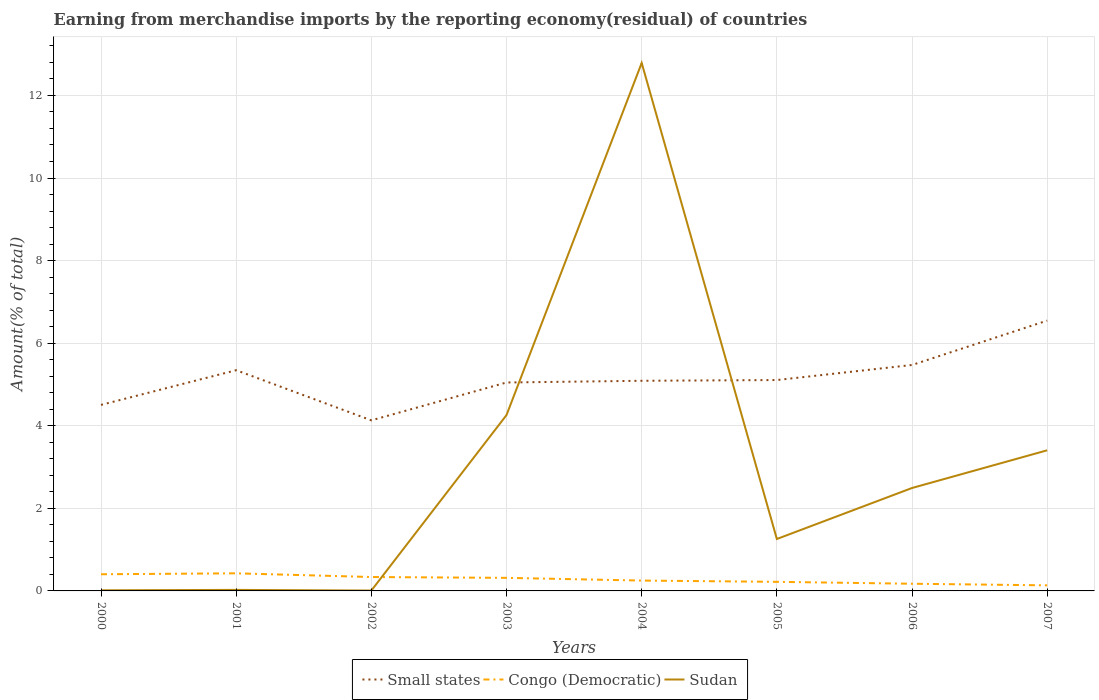Does the line corresponding to Sudan intersect with the line corresponding to Small states?
Keep it short and to the point. Yes. Is the number of lines equal to the number of legend labels?
Ensure brevity in your answer.  Yes. Across all years, what is the maximum percentage of amount earned from merchandise imports in Congo (Democratic)?
Offer a very short reply. 0.14. What is the total percentage of amount earned from merchandise imports in Small states in the graph?
Provide a succinct answer. -1.07. What is the difference between the highest and the second highest percentage of amount earned from merchandise imports in Congo (Democratic)?
Ensure brevity in your answer.  0.29. What is the difference between the highest and the lowest percentage of amount earned from merchandise imports in Sudan?
Keep it short and to the point. 3. Is the percentage of amount earned from merchandise imports in Small states strictly greater than the percentage of amount earned from merchandise imports in Sudan over the years?
Your response must be concise. No. What is the difference between two consecutive major ticks on the Y-axis?
Give a very brief answer. 2. Are the values on the major ticks of Y-axis written in scientific E-notation?
Make the answer very short. No. Does the graph contain grids?
Provide a short and direct response. Yes. How are the legend labels stacked?
Give a very brief answer. Horizontal. What is the title of the graph?
Provide a short and direct response. Earning from merchandise imports by the reporting economy(residual) of countries. Does "Aruba" appear as one of the legend labels in the graph?
Provide a succinct answer. No. What is the label or title of the X-axis?
Your answer should be compact. Years. What is the label or title of the Y-axis?
Give a very brief answer. Amount(% of total). What is the Amount(% of total) in Small states in 2000?
Your answer should be very brief. 4.51. What is the Amount(% of total) of Congo (Democratic) in 2000?
Make the answer very short. 0.4. What is the Amount(% of total) in Sudan in 2000?
Offer a terse response. 0.02. What is the Amount(% of total) in Small states in 2001?
Provide a short and direct response. 5.35. What is the Amount(% of total) of Congo (Democratic) in 2001?
Make the answer very short. 0.43. What is the Amount(% of total) of Sudan in 2001?
Offer a very short reply. 0.02. What is the Amount(% of total) in Small states in 2002?
Your answer should be compact. 4.13. What is the Amount(% of total) of Congo (Democratic) in 2002?
Keep it short and to the point. 0.34. What is the Amount(% of total) in Sudan in 2002?
Make the answer very short. 0.01. What is the Amount(% of total) in Small states in 2003?
Make the answer very short. 5.05. What is the Amount(% of total) of Congo (Democratic) in 2003?
Give a very brief answer. 0.32. What is the Amount(% of total) in Sudan in 2003?
Ensure brevity in your answer.  4.26. What is the Amount(% of total) of Small states in 2004?
Offer a very short reply. 5.09. What is the Amount(% of total) of Congo (Democratic) in 2004?
Give a very brief answer. 0.25. What is the Amount(% of total) of Sudan in 2004?
Provide a succinct answer. 12.79. What is the Amount(% of total) of Small states in 2005?
Provide a succinct answer. 5.11. What is the Amount(% of total) in Congo (Democratic) in 2005?
Your response must be concise. 0.22. What is the Amount(% of total) of Sudan in 2005?
Your response must be concise. 1.26. What is the Amount(% of total) of Small states in 2006?
Give a very brief answer. 5.47. What is the Amount(% of total) in Congo (Democratic) in 2006?
Offer a terse response. 0.17. What is the Amount(% of total) of Sudan in 2006?
Provide a short and direct response. 2.49. What is the Amount(% of total) of Small states in 2007?
Provide a succinct answer. 6.55. What is the Amount(% of total) of Congo (Democratic) in 2007?
Provide a short and direct response. 0.14. What is the Amount(% of total) of Sudan in 2007?
Ensure brevity in your answer.  3.41. Across all years, what is the maximum Amount(% of total) of Small states?
Your response must be concise. 6.55. Across all years, what is the maximum Amount(% of total) in Congo (Democratic)?
Ensure brevity in your answer.  0.43. Across all years, what is the maximum Amount(% of total) of Sudan?
Your answer should be very brief. 12.79. Across all years, what is the minimum Amount(% of total) in Small states?
Provide a short and direct response. 4.13. Across all years, what is the minimum Amount(% of total) in Congo (Democratic)?
Give a very brief answer. 0.14. Across all years, what is the minimum Amount(% of total) of Sudan?
Make the answer very short. 0.01. What is the total Amount(% of total) in Small states in the graph?
Your answer should be very brief. 41.24. What is the total Amount(% of total) in Congo (Democratic) in the graph?
Your answer should be compact. 2.26. What is the total Amount(% of total) in Sudan in the graph?
Your answer should be very brief. 24.25. What is the difference between the Amount(% of total) of Small states in 2000 and that in 2001?
Your response must be concise. -0.84. What is the difference between the Amount(% of total) of Congo (Democratic) in 2000 and that in 2001?
Offer a very short reply. -0.02. What is the difference between the Amount(% of total) in Sudan in 2000 and that in 2001?
Offer a very short reply. -0.01. What is the difference between the Amount(% of total) of Small states in 2000 and that in 2002?
Make the answer very short. 0.37. What is the difference between the Amount(% of total) in Congo (Democratic) in 2000 and that in 2002?
Keep it short and to the point. 0.07. What is the difference between the Amount(% of total) in Sudan in 2000 and that in 2002?
Keep it short and to the point. 0.01. What is the difference between the Amount(% of total) of Small states in 2000 and that in 2003?
Ensure brevity in your answer.  -0.54. What is the difference between the Amount(% of total) of Congo (Democratic) in 2000 and that in 2003?
Your response must be concise. 0.09. What is the difference between the Amount(% of total) in Sudan in 2000 and that in 2003?
Your response must be concise. -4.24. What is the difference between the Amount(% of total) of Small states in 2000 and that in 2004?
Provide a succinct answer. -0.58. What is the difference between the Amount(% of total) in Congo (Democratic) in 2000 and that in 2004?
Offer a terse response. 0.15. What is the difference between the Amount(% of total) of Sudan in 2000 and that in 2004?
Ensure brevity in your answer.  -12.77. What is the difference between the Amount(% of total) of Small states in 2000 and that in 2005?
Provide a succinct answer. -0.6. What is the difference between the Amount(% of total) of Congo (Democratic) in 2000 and that in 2005?
Keep it short and to the point. 0.18. What is the difference between the Amount(% of total) in Sudan in 2000 and that in 2005?
Make the answer very short. -1.24. What is the difference between the Amount(% of total) in Small states in 2000 and that in 2006?
Give a very brief answer. -0.97. What is the difference between the Amount(% of total) in Congo (Democratic) in 2000 and that in 2006?
Keep it short and to the point. 0.23. What is the difference between the Amount(% of total) in Sudan in 2000 and that in 2006?
Offer a very short reply. -2.48. What is the difference between the Amount(% of total) in Small states in 2000 and that in 2007?
Your response must be concise. -2.04. What is the difference between the Amount(% of total) of Congo (Democratic) in 2000 and that in 2007?
Provide a succinct answer. 0.27. What is the difference between the Amount(% of total) of Sudan in 2000 and that in 2007?
Ensure brevity in your answer.  -3.39. What is the difference between the Amount(% of total) of Small states in 2001 and that in 2002?
Offer a very short reply. 1.21. What is the difference between the Amount(% of total) in Congo (Democratic) in 2001 and that in 2002?
Ensure brevity in your answer.  0.09. What is the difference between the Amount(% of total) of Sudan in 2001 and that in 2002?
Provide a short and direct response. 0.02. What is the difference between the Amount(% of total) of Small states in 2001 and that in 2003?
Offer a terse response. 0.3. What is the difference between the Amount(% of total) in Congo (Democratic) in 2001 and that in 2003?
Make the answer very short. 0.11. What is the difference between the Amount(% of total) in Sudan in 2001 and that in 2003?
Your response must be concise. -4.23. What is the difference between the Amount(% of total) in Small states in 2001 and that in 2004?
Your response must be concise. 0.26. What is the difference between the Amount(% of total) of Congo (Democratic) in 2001 and that in 2004?
Ensure brevity in your answer.  0.18. What is the difference between the Amount(% of total) of Sudan in 2001 and that in 2004?
Your response must be concise. -12.76. What is the difference between the Amount(% of total) in Small states in 2001 and that in 2005?
Offer a very short reply. 0.24. What is the difference between the Amount(% of total) in Congo (Democratic) in 2001 and that in 2005?
Give a very brief answer. 0.21. What is the difference between the Amount(% of total) in Sudan in 2001 and that in 2005?
Make the answer very short. -1.23. What is the difference between the Amount(% of total) in Small states in 2001 and that in 2006?
Ensure brevity in your answer.  -0.13. What is the difference between the Amount(% of total) of Congo (Democratic) in 2001 and that in 2006?
Offer a terse response. 0.25. What is the difference between the Amount(% of total) of Sudan in 2001 and that in 2006?
Keep it short and to the point. -2.47. What is the difference between the Amount(% of total) of Small states in 2001 and that in 2007?
Offer a very short reply. -1.2. What is the difference between the Amount(% of total) in Congo (Democratic) in 2001 and that in 2007?
Offer a very short reply. 0.29. What is the difference between the Amount(% of total) of Sudan in 2001 and that in 2007?
Your answer should be compact. -3.38. What is the difference between the Amount(% of total) of Small states in 2002 and that in 2003?
Give a very brief answer. -0.92. What is the difference between the Amount(% of total) of Congo (Democratic) in 2002 and that in 2003?
Your response must be concise. 0.02. What is the difference between the Amount(% of total) in Sudan in 2002 and that in 2003?
Offer a terse response. -4.25. What is the difference between the Amount(% of total) in Small states in 2002 and that in 2004?
Offer a very short reply. -0.96. What is the difference between the Amount(% of total) in Congo (Democratic) in 2002 and that in 2004?
Your answer should be very brief. 0.09. What is the difference between the Amount(% of total) in Sudan in 2002 and that in 2004?
Offer a very short reply. -12.78. What is the difference between the Amount(% of total) of Small states in 2002 and that in 2005?
Offer a very short reply. -0.98. What is the difference between the Amount(% of total) of Congo (Democratic) in 2002 and that in 2005?
Your response must be concise. 0.12. What is the difference between the Amount(% of total) in Sudan in 2002 and that in 2005?
Ensure brevity in your answer.  -1.25. What is the difference between the Amount(% of total) in Small states in 2002 and that in 2006?
Offer a terse response. -1.34. What is the difference between the Amount(% of total) in Congo (Democratic) in 2002 and that in 2006?
Your response must be concise. 0.16. What is the difference between the Amount(% of total) in Sudan in 2002 and that in 2006?
Offer a very short reply. -2.48. What is the difference between the Amount(% of total) in Small states in 2002 and that in 2007?
Offer a very short reply. -2.42. What is the difference between the Amount(% of total) in Congo (Democratic) in 2002 and that in 2007?
Offer a terse response. 0.2. What is the difference between the Amount(% of total) of Sudan in 2002 and that in 2007?
Offer a very short reply. -3.4. What is the difference between the Amount(% of total) of Small states in 2003 and that in 2004?
Offer a very short reply. -0.04. What is the difference between the Amount(% of total) of Congo (Democratic) in 2003 and that in 2004?
Provide a succinct answer. 0.07. What is the difference between the Amount(% of total) of Sudan in 2003 and that in 2004?
Provide a succinct answer. -8.53. What is the difference between the Amount(% of total) of Small states in 2003 and that in 2005?
Give a very brief answer. -0.06. What is the difference between the Amount(% of total) of Congo (Democratic) in 2003 and that in 2005?
Your response must be concise. 0.1. What is the difference between the Amount(% of total) in Sudan in 2003 and that in 2005?
Ensure brevity in your answer.  3. What is the difference between the Amount(% of total) of Small states in 2003 and that in 2006?
Keep it short and to the point. -0.42. What is the difference between the Amount(% of total) of Congo (Democratic) in 2003 and that in 2006?
Offer a very short reply. 0.14. What is the difference between the Amount(% of total) in Sudan in 2003 and that in 2006?
Make the answer very short. 1.77. What is the difference between the Amount(% of total) of Small states in 2003 and that in 2007?
Offer a terse response. -1.5. What is the difference between the Amount(% of total) in Congo (Democratic) in 2003 and that in 2007?
Provide a succinct answer. 0.18. What is the difference between the Amount(% of total) of Sudan in 2003 and that in 2007?
Give a very brief answer. 0.85. What is the difference between the Amount(% of total) in Small states in 2004 and that in 2005?
Provide a succinct answer. -0.02. What is the difference between the Amount(% of total) of Congo (Democratic) in 2004 and that in 2005?
Offer a terse response. 0.03. What is the difference between the Amount(% of total) of Sudan in 2004 and that in 2005?
Make the answer very short. 11.53. What is the difference between the Amount(% of total) in Small states in 2004 and that in 2006?
Provide a succinct answer. -0.38. What is the difference between the Amount(% of total) in Congo (Democratic) in 2004 and that in 2006?
Offer a very short reply. 0.08. What is the difference between the Amount(% of total) of Sudan in 2004 and that in 2006?
Offer a terse response. 10.29. What is the difference between the Amount(% of total) in Small states in 2004 and that in 2007?
Ensure brevity in your answer.  -1.46. What is the difference between the Amount(% of total) in Congo (Democratic) in 2004 and that in 2007?
Offer a terse response. 0.12. What is the difference between the Amount(% of total) of Sudan in 2004 and that in 2007?
Give a very brief answer. 9.38. What is the difference between the Amount(% of total) of Small states in 2005 and that in 2006?
Ensure brevity in your answer.  -0.36. What is the difference between the Amount(% of total) in Congo (Democratic) in 2005 and that in 2006?
Make the answer very short. 0.05. What is the difference between the Amount(% of total) in Sudan in 2005 and that in 2006?
Ensure brevity in your answer.  -1.24. What is the difference between the Amount(% of total) in Small states in 2005 and that in 2007?
Your response must be concise. -1.44. What is the difference between the Amount(% of total) of Congo (Democratic) in 2005 and that in 2007?
Provide a short and direct response. 0.09. What is the difference between the Amount(% of total) of Sudan in 2005 and that in 2007?
Keep it short and to the point. -2.15. What is the difference between the Amount(% of total) in Small states in 2006 and that in 2007?
Offer a very short reply. -1.07. What is the difference between the Amount(% of total) in Congo (Democratic) in 2006 and that in 2007?
Your answer should be very brief. 0.04. What is the difference between the Amount(% of total) in Sudan in 2006 and that in 2007?
Give a very brief answer. -0.91. What is the difference between the Amount(% of total) of Small states in 2000 and the Amount(% of total) of Congo (Democratic) in 2001?
Provide a succinct answer. 4.08. What is the difference between the Amount(% of total) in Small states in 2000 and the Amount(% of total) in Sudan in 2001?
Your answer should be compact. 4.48. What is the difference between the Amount(% of total) in Congo (Democratic) in 2000 and the Amount(% of total) in Sudan in 2001?
Your response must be concise. 0.38. What is the difference between the Amount(% of total) of Small states in 2000 and the Amount(% of total) of Congo (Democratic) in 2002?
Ensure brevity in your answer.  4.17. What is the difference between the Amount(% of total) of Small states in 2000 and the Amount(% of total) of Sudan in 2002?
Provide a succinct answer. 4.5. What is the difference between the Amount(% of total) of Congo (Democratic) in 2000 and the Amount(% of total) of Sudan in 2002?
Give a very brief answer. 0.39. What is the difference between the Amount(% of total) of Small states in 2000 and the Amount(% of total) of Congo (Democratic) in 2003?
Give a very brief answer. 4.19. What is the difference between the Amount(% of total) in Small states in 2000 and the Amount(% of total) in Sudan in 2003?
Provide a short and direct response. 0.25. What is the difference between the Amount(% of total) in Congo (Democratic) in 2000 and the Amount(% of total) in Sudan in 2003?
Offer a terse response. -3.86. What is the difference between the Amount(% of total) in Small states in 2000 and the Amount(% of total) in Congo (Democratic) in 2004?
Your answer should be very brief. 4.25. What is the difference between the Amount(% of total) in Small states in 2000 and the Amount(% of total) in Sudan in 2004?
Provide a succinct answer. -8.28. What is the difference between the Amount(% of total) in Congo (Democratic) in 2000 and the Amount(% of total) in Sudan in 2004?
Ensure brevity in your answer.  -12.38. What is the difference between the Amount(% of total) in Small states in 2000 and the Amount(% of total) in Congo (Democratic) in 2005?
Give a very brief answer. 4.29. What is the difference between the Amount(% of total) of Small states in 2000 and the Amount(% of total) of Sudan in 2005?
Offer a terse response. 3.25. What is the difference between the Amount(% of total) in Congo (Democratic) in 2000 and the Amount(% of total) in Sudan in 2005?
Provide a succinct answer. -0.85. What is the difference between the Amount(% of total) in Small states in 2000 and the Amount(% of total) in Congo (Democratic) in 2006?
Give a very brief answer. 4.33. What is the difference between the Amount(% of total) in Small states in 2000 and the Amount(% of total) in Sudan in 2006?
Ensure brevity in your answer.  2.01. What is the difference between the Amount(% of total) in Congo (Democratic) in 2000 and the Amount(% of total) in Sudan in 2006?
Offer a terse response. -2.09. What is the difference between the Amount(% of total) in Small states in 2000 and the Amount(% of total) in Congo (Democratic) in 2007?
Make the answer very short. 4.37. What is the difference between the Amount(% of total) in Small states in 2000 and the Amount(% of total) in Sudan in 2007?
Ensure brevity in your answer.  1.1. What is the difference between the Amount(% of total) in Congo (Democratic) in 2000 and the Amount(% of total) in Sudan in 2007?
Offer a very short reply. -3. What is the difference between the Amount(% of total) of Small states in 2001 and the Amount(% of total) of Congo (Democratic) in 2002?
Offer a very short reply. 5.01. What is the difference between the Amount(% of total) in Small states in 2001 and the Amount(% of total) in Sudan in 2002?
Offer a very short reply. 5.34. What is the difference between the Amount(% of total) in Congo (Democratic) in 2001 and the Amount(% of total) in Sudan in 2002?
Offer a terse response. 0.42. What is the difference between the Amount(% of total) of Small states in 2001 and the Amount(% of total) of Congo (Democratic) in 2003?
Offer a very short reply. 5.03. What is the difference between the Amount(% of total) of Small states in 2001 and the Amount(% of total) of Sudan in 2003?
Make the answer very short. 1.09. What is the difference between the Amount(% of total) of Congo (Democratic) in 2001 and the Amount(% of total) of Sudan in 2003?
Your answer should be compact. -3.83. What is the difference between the Amount(% of total) in Small states in 2001 and the Amount(% of total) in Congo (Democratic) in 2004?
Make the answer very short. 5.09. What is the difference between the Amount(% of total) in Small states in 2001 and the Amount(% of total) in Sudan in 2004?
Provide a succinct answer. -7.44. What is the difference between the Amount(% of total) of Congo (Democratic) in 2001 and the Amount(% of total) of Sudan in 2004?
Make the answer very short. -12.36. What is the difference between the Amount(% of total) in Small states in 2001 and the Amount(% of total) in Congo (Democratic) in 2005?
Keep it short and to the point. 5.13. What is the difference between the Amount(% of total) of Small states in 2001 and the Amount(% of total) of Sudan in 2005?
Offer a terse response. 4.09. What is the difference between the Amount(% of total) of Congo (Democratic) in 2001 and the Amount(% of total) of Sudan in 2005?
Ensure brevity in your answer.  -0.83. What is the difference between the Amount(% of total) of Small states in 2001 and the Amount(% of total) of Congo (Democratic) in 2006?
Ensure brevity in your answer.  5.17. What is the difference between the Amount(% of total) in Small states in 2001 and the Amount(% of total) in Sudan in 2006?
Keep it short and to the point. 2.85. What is the difference between the Amount(% of total) in Congo (Democratic) in 2001 and the Amount(% of total) in Sudan in 2006?
Give a very brief answer. -2.07. What is the difference between the Amount(% of total) of Small states in 2001 and the Amount(% of total) of Congo (Democratic) in 2007?
Provide a short and direct response. 5.21. What is the difference between the Amount(% of total) in Small states in 2001 and the Amount(% of total) in Sudan in 2007?
Provide a short and direct response. 1.94. What is the difference between the Amount(% of total) of Congo (Democratic) in 2001 and the Amount(% of total) of Sudan in 2007?
Give a very brief answer. -2.98. What is the difference between the Amount(% of total) in Small states in 2002 and the Amount(% of total) in Congo (Democratic) in 2003?
Offer a very short reply. 3.81. What is the difference between the Amount(% of total) in Small states in 2002 and the Amount(% of total) in Sudan in 2003?
Your response must be concise. -0.13. What is the difference between the Amount(% of total) of Congo (Democratic) in 2002 and the Amount(% of total) of Sudan in 2003?
Ensure brevity in your answer.  -3.92. What is the difference between the Amount(% of total) in Small states in 2002 and the Amount(% of total) in Congo (Democratic) in 2004?
Your answer should be very brief. 3.88. What is the difference between the Amount(% of total) in Small states in 2002 and the Amount(% of total) in Sudan in 2004?
Provide a short and direct response. -8.66. What is the difference between the Amount(% of total) in Congo (Democratic) in 2002 and the Amount(% of total) in Sudan in 2004?
Your answer should be very brief. -12.45. What is the difference between the Amount(% of total) of Small states in 2002 and the Amount(% of total) of Congo (Democratic) in 2005?
Offer a terse response. 3.91. What is the difference between the Amount(% of total) in Small states in 2002 and the Amount(% of total) in Sudan in 2005?
Make the answer very short. 2.87. What is the difference between the Amount(% of total) of Congo (Democratic) in 2002 and the Amount(% of total) of Sudan in 2005?
Offer a terse response. -0.92. What is the difference between the Amount(% of total) in Small states in 2002 and the Amount(% of total) in Congo (Democratic) in 2006?
Keep it short and to the point. 3.96. What is the difference between the Amount(% of total) of Small states in 2002 and the Amount(% of total) of Sudan in 2006?
Your answer should be compact. 1.64. What is the difference between the Amount(% of total) of Congo (Democratic) in 2002 and the Amount(% of total) of Sudan in 2006?
Your response must be concise. -2.16. What is the difference between the Amount(% of total) of Small states in 2002 and the Amount(% of total) of Congo (Democratic) in 2007?
Make the answer very short. 4. What is the difference between the Amount(% of total) of Small states in 2002 and the Amount(% of total) of Sudan in 2007?
Your answer should be very brief. 0.73. What is the difference between the Amount(% of total) in Congo (Democratic) in 2002 and the Amount(% of total) in Sudan in 2007?
Offer a terse response. -3.07. What is the difference between the Amount(% of total) of Small states in 2003 and the Amount(% of total) of Congo (Democratic) in 2004?
Provide a short and direct response. 4.8. What is the difference between the Amount(% of total) in Small states in 2003 and the Amount(% of total) in Sudan in 2004?
Provide a succinct answer. -7.74. What is the difference between the Amount(% of total) in Congo (Democratic) in 2003 and the Amount(% of total) in Sudan in 2004?
Provide a short and direct response. -12.47. What is the difference between the Amount(% of total) in Small states in 2003 and the Amount(% of total) in Congo (Democratic) in 2005?
Your response must be concise. 4.83. What is the difference between the Amount(% of total) of Small states in 2003 and the Amount(% of total) of Sudan in 2005?
Keep it short and to the point. 3.79. What is the difference between the Amount(% of total) in Congo (Democratic) in 2003 and the Amount(% of total) in Sudan in 2005?
Keep it short and to the point. -0.94. What is the difference between the Amount(% of total) of Small states in 2003 and the Amount(% of total) of Congo (Democratic) in 2006?
Offer a very short reply. 4.87. What is the difference between the Amount(% of total) of Small states in 2003 and the Amount(% of total) of Sudan in 2006?
Offer a terse response. 2.56. What is the difference between the Amount(% of total) of Congo (Democratic) in 2003 and the Amount(% of total) of Sudan in 2006?
Keep it short and to the point. -2.18. What is the difference between the Amount(% of total) in Small states in 2003 and the Amount(% of total) in Congo (Democratic) in 2007?
Offer a very short reply. 4.91. What is the difference between the Amount(% of total) of Small states in 2003 and the Amount(% of total) of Sudan in 2007?
Keep it short and to the point. 1.64. What is the difference between the Amount(% of total) of Congo (Democratic) in 2003 and the Amount(% of total) of Sudan in 2007?
Offer a very short reply. -3.09. What is the difference between the Amount(% of total) in Small states in 2004 and the Amount(% of total) in Congo (Democratic) in 2005?
Make the answer very short. 4.87. What is the difference between the Amount(% of total) of Small states in 2004 and the Amount(% of total) of Sudan in 2005?
Give a very brief answer. 3.83. What is the difference between the Amount(% of total) of Congo (Democratic) in 2004 and the Amount(% of total) of Sudan in 2005?
Provide a short and direct response. -1.01. What is the difference between the Amount(% of total) of Small states in 2004 and the Amount(% of total) of Congo (Democratic) in 2006?
Keep it short and to the point. 4.92. What is the difference between the Amount(% of total) of Small states in 2004 and the Amount(% of total) of Sudan in 2006?
Your answer should be very brief. 2.6. What is the difference between the Amount(% of total) of Congo (Democratic) in 2004 and the Amount(% of total) of Sudan in 2006?
Keep it short and to the point. -2.24. What is the difference between the Amount(% of total) in Small states in 2004 and the Amount(% of total) in Congo (Democratic) in 2007?
Offer a terse response. 4.95. What is the difference between the Amount(% of total) of Small states in 2004 and the Amount(% of total) of Sudan in 2007?
Offer a very short reply. 1.68. What is the difference between the Amount(% of total) of Congo (Democratic) in 2004 and the Amount(% of total) of Sudan in 2007?
Offer a very short reply. -3.15. What is the difference between the Amount(% of total) in Small states in 2005 and the Amount(% of total) in Congo (Democratic) in 2006?
Provide a succinct answer. 4.93. What is the difference between the Amount(% of total) of Small states in 2005 and the Amount(% of total) of Sudan in 2006?
Your answer should be very brief. 2.61. What is the difference between the Amount(% of total) of Congo (Democratic) in 2005 and the Amount(% of total) of Sudan in 2006?
Give a very brief answer. -2.27. What is the difference between the Amount(% of total) of Small states in 2005 and the Amount(% of total) of Congo (Democratic) in 2007?
Your answer should be very brief. 4.97. What is the difference between the Amount(% of total) of Small states in 2005 and the Amount(% of total) of Sudan in 2007?
Offer a terse response. 1.7. What is the difference between the Amount(% of total) in Congo (Democratic) in 2005 and the Amount(% of total) in Sudan in 2007?
Provide a succinct answer. -3.19. What is the difference between the Amount(% of total) in Small states in 2006 and the Amount(% of total) in Congo (Democratic) in 2007?
Give a very brief answer. 5.34. What is the difference between the Amount(% of total) of Small states in 2006 and the Amount(% of total) of Sudan in 2007?
Give a very brief answer. 2.07. What is the difference between the Amount(% of total) of Congo (Democratic) in 2006 and the Amount(% of total) of Sudan in 2007?
Ensure brevity in your answer.  -3.23. What is the average Amount(% of total) of Small states per year?
Offer a terse response. 5.16. What is the average Amount(% of total) of Congo (Democratic) per year?
Your answer should be compact. 0.28. What is the average Amount(% of total) in Sudan per year?
Make the answer very short. 3.03. In the year 2000, what is the difference between the Amount(% of total) in Small states and Amount(% of total) in Congo (Democratic)?
Give a very brief answer. 4.1. In the year 2000, what is the difference between the Amount(% of total) of Small states and Amount(% of total) of Sudan?
Make the answer very short. 4.49. In the year 2000, what is the difference between the Amount(% of total) in Congo (Democratic) and Amount(% of total) in Sudan?
Provide a succinct answer. 0.39. In the year 2001, what is the difference between the Amount(% of total) of Small states and Amount(% of total) of Congo (Democratic)?
Provide a short and direct response. 4.92. In the year 2001, what is the difference between the Amount(% of total) in Small states and Amount(% of total) in Sudan?
Your response must be concise. 5.32. In the year 2001, what is the difference between the Amount(% of total) in Congo (Democratic) and Amount(% of total) in Sudan?
Offer a very short reply. 0.4. In the year 2002, what is the difference between the Amount(% of total) of Small states and Amount(% of total) of Congo (Democratic)?
Ensure brevity in your answer.  3.79. In the year 2002, what is the difference between the Amount(% of total) in Small states and Amount(% of total) in Sudan?
Ensure brevity in your answer.  4.12. In the year 2002, what is the difference between the Amount(% of total) of Congo (Democratic) and Amount(% of total) of Sudan?
Your answer should be very brief. 0.33. In the year 2003, what is the difference between the Amount(% of total) in Small states and Amount(% of total) in Congo (Democratic)?
Make the answer very short. 4.73. In the year 2003, what is the difference between the Amount(% of total) in Small states and Amount(% of total) in Sudan?
Provide a short and direct response. 0.79. In the year 2003, what is the difference between the Amount(% of total) in Congo (Democratic) and Amount(% of total) in Sudan?
Give a very brief answer. -3.94. In the year 2004, what is the difference between the Amount(% of total) in Small states and Amount(% of total) in Congo (Democratic)?
Your answer should be compact. 4.84. In the year 2004, what is the difference between the Amount(% of total) of Small states and Amount(% of total) of Sudan?
Offer a terse response. -7.7. In the year 2004, what is the difference between the Amount(% of total) of Congo (Democratic) and Amount(% of total) of Sudan?
Keep it short and to the point. -12.54. In the year 2005, what is the difference between the Amount(% of total) of Small states and Amount(% of total) of Congo (Democratic)?
Give a very brief answer. 4.89. In the year 2005, what is the difference between the Amount(% of total) of Small states and Amount(% of total) of Sudan?
Your response must be concise. 3.85. In the year 2005, what is the difference between the Amount(% of total) in Congo (Democratic) and Amount(% of total) in Sudan?
Keep it short and to the point. -1.04. In the year 2006, what is the difference between the Amount(% of total) in Small states and Amount(% of total) in Congo (Democratic)?
Your answer should be very brief. 5.3. In the year 2006, what is the difference between the Amount(% of total) of Small states and Amount(% of total) of Sudan?
Your answer should be compact. 2.98. In the year 2006, what is the difference between the Amount(% of total) of Congo (Democratic) and Amount(% of total) of Sudan?
Provide a succinct answer. -2.32. In the year 2007, what is the difference between the Amount(% of total) in Small states and Amount(% of total) in Congo (Democratic)?
Provide a short and direct response. 6.41. In the year 2007, what is the difference between the Amount(% of total) of Small states and Amount(% of total) of Sudan?
Your answer should be compact. 3.14. In the year 2007, what is the difference between the Amount(% of total) in Congo (Democratic) and Amount(% of total) in Sudan?
Your answer should be very brief. -3.27. What is the ratio of the Amount(% of total) of Small states in 2000 to that in 2001?
Provide a succinct answer. 0.84. What is the ratio of the Amount(% of total) in Congo (Democratic) in 2000 to that in 2001?
Offer a terse response. 0.95. What is the ratio of the Amount(% of total) in Sudan in 2000 to that in 2001?
Your response must be concise. 0.61. What is the ratio of the Amount(% of total) of Small states in 2000 to that in 2002?
Your answer should be very brief. 1.09. What is the ratio of the Amount(% of total) in Congo (Democratic) in 2000 to that in 2002?
Your answer should be very brief. 1.2. What is the ratio of the Amount(% of total) in Sudan in 2000 to that in 2002?
Keep it short and to the point. 1.69. What is the ratio of the Amount(% of total) of Small states in 2000 to that in 2003?
Provide a short and direct response. 0.89. What is the ratio of the Amount(% of total) of Congo (Democratic) in 2000 to that in 2003?
Give a very brief answer. 1.28. What is the ratio of the Amount(% of total) of Sudan in 2000 to that in 2003?
Provide a short and direct response. 0. What is the ratio of the Amount(% of total) in Small states in 2000 to that in 2004?
Your answer should be very brief. 0.89. What is the ratio of the Amount(% of total) of Congo (Democratic) in 2000 to that in 2004?
Offer a very short reply. 1.61. What is the ratio of the Amount(% of total) of Sudan in 2000 to that in 2004?
Provide a short and direct response. 0. What is the ratio of the Amount(% of total) in Small states in 2000 to that in 2005?
Give a very brief answer. 0.88. What is the ratio of the Amount(% of total) in Congo (Democratic) in 2000 to that in 2005?
Give a very brief answer. 1.83. What is the ratio of the Amount(% of total) of Sudan in 2000 to that in 2005?
Keep it short and to the point. 0.01. What is the ratio of the Amount(% of total) of Small states in 2000 to that in 2006?
Provide a short and direct response. 0.82. What is the ratio of the Amount(% of total) of Congo (Democratic) in 2000 to that in 2006?
Your answer should be compact. 2.32. What is the ratio of the Amount(% of total) in Sudan in 2000 to that in 2006?
Make the answer very short. 0.01. What is the ratio of the Amount(% of total) of Small states in 2000 to that in 2007?
Ensure brevity in your answer.  0.69. What is the ratio of the Amount(% of total) of Congo (Democratic) in 2000 to that in 2007?
Your answer should be very brief. 2.99. What is the ratio of the Amount(% of total) in Sudan in 2000 to that in 2007?
Make the answer very short. 0. What is the ratio of the Amount(% of total) of Small states in 2001 to that in 2002?
Your answer should be very brief. 1.29. What is the ratio of the Amount(% of total) of Congo (Democratic) in 2001 to that in 2002?
Your response must be concise. 1.27. What is the ratio of the Amount(% of total) in Sudan in 2001 to that in 2002?
Keep it short and to the point. 2.8. What is the ratio of the Amount(% of total) of Small states in 2001 to that in 2003?
Provide a short and direct response. 1.06. What is the ratio of the Amount(% of total) of Congo (Democratic) in 2001 to that in 2003?
Ensure brevity in your answer.  1.35. What is the ratio of the Amount(% of total) of Sudan in 2001 to that in 2003?
Provide a succinct answer. 0.01. What is the ratio of the Amount(% of total) of Small states in 2001 to that in 2004?
Give a very brief answer. 1.05. What is the ratio of the Amount(% of total) in Congo (Democratic) in 2001 to that in 2004?
Your answer should be compact. 1.7. What is the ratio of the Amount(% of total) of Sudan in 2001 to that in 2004?
Offer a terse response. 0. What is the ratio of the Amount(% of total) of Small states in 2001 to that in 2005?
Offer a very short reply. 1.05. What is the ratio of the Amount(% of total) of Congo (Democratic) in 2001 to that in 2005?
Give a very brief answer. 1.94. What is the ratio of the Amount(% of total) in Sudan in 2001 to that in 2005?
Your answer should be very brief. 0.02. What is the ratio of the Amount(% of total) in Small states in 2001 to that in 2006?
Keep it short and to the point. 0.98. What is the ratio of the Amount(% of total) in Congo (Democratic) in 2001 to that in 2006?
Ensure brevity in your answer.  2.45. What is the ratio of the Amount(% of total) of Sudan in 2001 to that in 2006?
Give a very brief answer. 0.01. What is the ratio of the Amount(% of total) in Small states in 2001 to that in 2007?
Provide a succinct answer. 0.82. What is the ratio of the Amount(% of total) in Congo (Democratic) in 2001 to that in 2007?
Your answer should be compact. 3.16. What is the ratio of the Amount(% of total) of Sudan in 2001 to that in 2007?
Keep it short and to the point. 0.01. What is the ratio of the Amount(% of total) in Small states in 2002 to that in 2003?
Give a very brief answer. 0.82. What is the ratio of the Amount(% of total) of Congo (Democratic) in 2002 to that in 2003?
Ensure brevity in your answer.  1.06. What is the ratio of the Amount(% of total) in Sudan in 2002 to that in 2003?
Make the answer very short. 0. What is the ratio of the Amount(% of total) of Small states in 2002 to that in 2004?
Provide a succinct answer. 0.81. What is the ratio of the Amount(% of total) of Congo (Democratic) in 2002 to that in 2004?
Keep it short and to the point. 1.34. What is the ratio of the Amount(% of total) of Sudan in 2002 to that in 2004?
Make the answer very short. 0. What is the ratio of the Amount(% of total) in Small states in 2002 to that in 2005?
Give a very brief answer. 0.81. What is the ratio of the Amount(% of total) of Congo (Democratic) in 2002 to that in 2005?
Give a very brief answer. 1.53. What is the ratio of the Amount(% of total) in Sudan in 2002 to that in 2005?
Offer a terse response. 0.01. What is the ratio of the Amount(% of total) of Small states in 2002 to that in 2006?
Your response must be concise. 0.76. What is the ratio of the Amount(% of total) in Congo (Democratic) in 2002 to that in 2006?
Give a very brief answer. 1.93. What is the ratio of the Amount(% of total) of Sudan in 2002 to that in 2006?
Provide a short and direct response. 0. What is the ratio of the Amount(% of total) in Small states in 2002 to that in 2007?
Give a very brief answer. 0.63. What is the ratio of the Amount(% of total) in Congo (Democratic) in 2002 to that in 2007?
Ensure brevity in your answer.  2.49. What is the ratio of the Amount(% of total) in Sudan in 2002 to that in 2007?
Your response must be concise. 0. What is the ratio of the Amount(% of total) of Small states in 2003 to that in 2004?
Offer a terse response. 0.99. What is the ratio of the Amount(% of total) of Congo (Democratic) in 2003 to that in 2004?
Ensure brevity in your answer.  1.26. What is the ratio of the Amount(% of total) of Sudan in 2003 to that in 2004?
Make the answer very short. 0.33. What is the ratio of the Amount(% of total) of Small states in 2003 to that in 2005?
Ensure brevity in your answer.  0.99. What is the ratio of the Amount(% of total) in Congo (Democratic) in 2003 to that in 2005?
Provide a succinct answer. 1.44. What is the ratio of the Amount(% of total) of Sudan in 2003 to that in 2005?
Your response must be concise. 3.39. What is the ratio of the Amount(% of total) of Small states in 2003 to that in 2006?
Offer a very short reply. 0.92. What is the ratio of the Amount(% of total) of Congo (Democratic) in 2003 to that in 2006?
Give a very brief answer. 1.82. What is the ratio of the Amount(% of total) of Sudan in 2003 to that in 2006?
Keep it short and to the point. 1.71. What is the ratio of the Amount(% of total) in Small states in 2003 to that in 2007?
Keep it short and to the point. 0.77. What is the ratio of the Amount(% of total) of Congo (Democratic) in 2003 to that in 2007?
Your answer should be compact. 2.34. What is the ratio of the Amount(% of total) in Sudan in 2003 to that in 2007?
Make the answer very short. 1.25. What is the ratio of the Amount(% of total) in Congo (Democratic) in 2004 to that in 2005?
Your answer should be compact. 1.14. What is the ratio of the Amount(% of total) in Sudan in 2004 to that in 2005?
Your answer should be very brief. 10.17. What is the ratio of the Amount(% of total) in Small states in 2004 to that in 2006?
Provide a short and direct response. 0.93. What is the ratio of the Amount(% of total) in Congo (Democratic) in 2004 to that in 2006?
Provide a succinct answer. 1.44. What is the ratio of the Amount(% of total) of Sudan in 2004 to that in 2006?
Provide a succinct answer. 5.13. What is the ratio of the Amount(% of total) in Small states in 2004 to that in 2007?
Your response must be concise. 0.78. What is the ratio of the Amount(% of total) of Congo (Democratic) in 2004 to that in 2007?
Ensure brevity in your answer.  1.86. What is the ratio of the Amount(% of total) in Sudan in 2004 to that in 2007?
Provide a short and direct response. 3.75. What is the ratio of the Amount(% of total) of Small states in 2005 to that in 2006?
Provide a succinct answer. 0.93. What is the ratio of the Amount(% of total) of Congo (Democratic) in 2005 to that in 2006?
Ensure brevity in your answer.  1.26. What is the ratio of the Amount(% of total) in Sudan in 2005 to that in 2006?
Provide a short and direct response. 0.5. What is the ratio of the Amount(% of total) in Small states in 2005 to that in 2007?
Offer a very short reply. 0.78. What is the ratio of the Amount(% of total) of Congo (Democratic) in 2005 to that in 2007?
Your response must be concise. 1.63. What is the ratio of the Amount(% of total) in Sudan in 2005 to that in 2007?
Keep it short and to the point. 0.37. What is the ratio of the Amount(% of total) of Small states in 2006 to that in 2007?
Make the answer very short. 0.84. What is the ratio of the Amount(% of total) of Congo (Democratic) in 2006 to that in 2007?
Provide a short and direct response. 1.29. What is the ratio of the Amount(% of total) of Sudan in 2006 to that in 2007?
Your answer should be very brief. 0.73. What is the difference between the highest and the second highest Amount(% of total) of Small states?
Keep it short and to the point. 1.07. What is the difference between the highest and the second highest Amount(% of total) in Congo (Democratic)?
Provide a short and direct response. 0.02. What is the difference between the highest and the second highest Amount(% of total) of Sudan?
Your answer should be very brief. 8.53. What is the difference between the highest and the lowest Amount(% of total) in Small states?
Ensure brevity in your answer.  2.42. What is the difference between the highest and the lowest Amount(% of total) in Congo (Democratic)?
Your response must be concise. 0.29. What is the difference between the highest and the lowest Amount(% of total) of Sudan?
Make the answer very short. 12.78. 